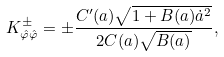Convert formula to latex. <formula><loc_0><loc_0><loc_500><loc_500>K _ { \hat { \varphi } \hat { \varphi } } ^ { \pm } = \pm \frac { C ^ { \prime } ( a ) \sqrt { 1 + B ( a ) \dot { a } ^ { 2 } } } { 2 C ( a ) \sqrt { B ( a ) } } ,</formula> 